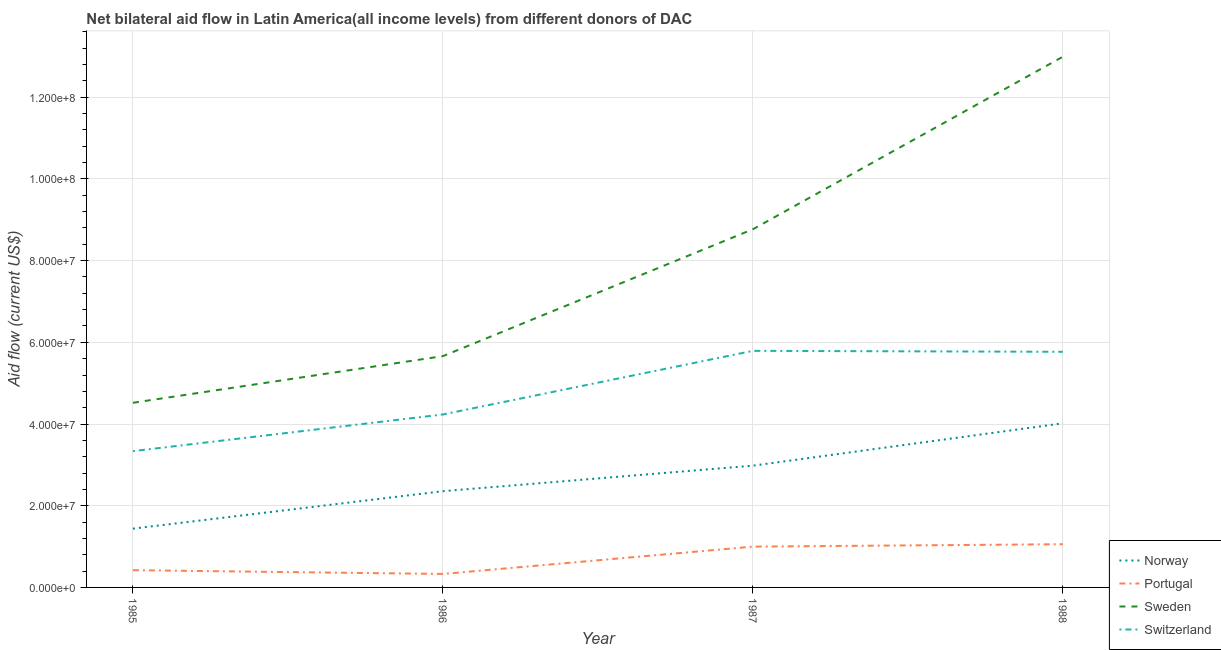How many different coloured lines are there?
Offer a terse response. 4. What is the amount of aid given by norway in 1988?
Your answer should be compact. 4.02e+07. Across all years, what is the maximum amount of aid given by sweden?
Your answer should be very brief. 1.30e+08. Across all years, what is the minimum amount of aid given by sweden?
Offer a terse response. 4.52e+07. What is the total amount of aid given by portugal in the graph?
Make the answer very short. 2.81e+07. What is the difference between the amount of aid given by portugal in 1985 and that in 1988?
Ensure brevity in your answer.  -6.36e+06. What is the difference between the amount of aid given by switzerland in 1988 and the amount of aid given by norway in 1986?
Your answer should be very brief. 3.41e+07. What is the average amount of aid given by switzerland per year?
Your answer should be very brief. 4.78e+07. In the year 1986, what is the difference between the amount of aid given by sweden and amount of aid given by portugal?
Give a very brief answer. 5.33e+07. In how many years, is the amount of aid given by sweden greater than 40000000 US$?
Ensure brevity in your answer.  4. What is the ratio of the amount of aid given by norway in 1985 to that in 1988?
Keep it short and to the point. 0.36. What is the difference between the highest and the second highest amount of aid given by sweden?
Make the answer very short. 4.22e+07. What is the difference between the highest and the lowest amount of aid given by portugal?
Give a very brief answer. 7.28e+06. In how many years, is the amount of aid given by switzerland greater than the average amount of aid given by switzerland taken over all years?
Make the answer very short. 2. Is the sum of the amount of aid given by norway in 1985 and 1986 greater than the maximum amount of aid given by sweden across all years?
Make the answer very short. No. Is it the case that in every year, the sum of the amount of aid given by norway and amount of aid given by sweden is greater than the sum of amount of aid given by switzerland and amount of aid given by portugal?
Your answer should be very brief. Yes. Does the amount of aid given by portugal monotonically increase over the years?
Offer a very short reply. No. Is the amount of aid given by switzerland strictly greater than the amount of aid given by portugal over the years?
Your response must be concise. Yes. How many years are there in the graph?
Your response must be concise. 4. What is the difference between two consecutive major ticks on the Y-axis?
Give a very brief answer. 2.00e+07. Are the values on the major ticks of Y-axis written in scientific E-notation?
Give a very brief answer. Yes. Does the graph contain grids?
Your answer should be compact. Yes. How many legend labels are there?
Offer a very short reply. 4. How are the legend labels stacked?
Offer a very short reply. Vertical. What is the title of the graph?
Offer a very short reply. Net bilateral aid flow in Latin America(all income levels) from different donors of DAC. Does "Secondary vocational" appear as one of the legend labels in the graph?
Give a very brief answer. No. What is the label or title of the X-axis?
Your answer should be compact. Year. What is the Aid flow (current US$) of Norway in 1985?
Ensure brevity in your answer.  1.44e+07. What is the Aid flow (current US$) in Portugal in 1985?
Your answer should be compact. 4.22e+06. What is the Aid flow (current US$) of Sweden in 1985?
Give a very brief answer. 4.52e+07. What is the Aid flow (current US$) of Switzerland in 1985?
Provide a succinct answer. 3.34e+07. What is the Aid flow (current US$) of Norway in 1986?
Keep it short and to the point. 2.36e+07. What is the Aid flow (current US$) in Portugal in 1986?
Make the answer very short. 3.30e+06. What is the Aid flow (current US$) of Sweden in 1986?
Keep it short and to the point. 5.66e+07. What is the Aid flow (current US$) in Switzerland in 1986?
Offer a very short reply. 4.23e+07. What is the Aid flow (current US$) in Norway in 1987?
Give a very brief answer. 2.98e+07. What is the Aid flow (current US$) of Portugal in 1987?
Keep it short and to the point. 9.99e+06. What is the Aid flow (current US$) of Sweden in 1987?
Offer a very short reply. 8.77e+07. What is the Aid flow (current US$) of Switzerland in 1987?
Offer a terse response. 5.79e+07. What is the Aid flow (current US$) of Norway in 1988?
Offer a terse response. 4.02e+07. What is the Aid flow (current US$) in Portugal in 1988?
Ensure brevity in your answer.  1.06e+07. What is the Aid flow (current US$) in Sweden in 1988?
Provide a short and direct response. 1.30e+08. What is the Aid flow (current US$) of Switzerland in 1988?
Ensure brevity in your answer.  5.77e+07. Across all years, what is the maximum Aid flow (current US$) in Norway?
Ensure brevity in your answer.  4.02e+07. Across all years, what is the maximum Aid flow (current US$) in Portugal?
Offer a terse response. 1.06e+07. Across all years, what is the maximum Aid flow (current US$) of Sweden?
Your answer should be compact. 1.30e+08. Across all years, what is the maximum Aid flow (current US$) in Switzerland?
Provide a succinct answer. 5.79e+07. Across all years, what is the minimum Aid flow (current US$) in Norway?
Your answer should be very brief. 1.44e+07. Across all years, what is the minimum Aid flow (current US$) of Portugal?
Offer a terse response. 3.30e+06. Across all years, what is the minimum Aid flow (current US$) of Sweden?
Keep it short and to the point. 4.52e+07. Across all years, what is the minimum Aid flow (current US$) in Switzerland?
Your response must be concise. 3.34e+07. What is the total Aid flow (current US$) in Norway in the graph?
Make the answer very short. 1.08e+08. What is the total Aid flow (current US$) in Portugal in the graph?
Provide a short and direct response. 2.81e+07. What is the total Aid flow (current US$) in Sweden in the graph?
Provide a succinct answer. 3.19e+08. What is the total Aid flow (current US$) in Switzerland in the graph?
Provide a succinct answer. 1.91e+08. What is the difference between the Aid flow (current US$) in Norway in 1985 and that in 1986?
Provide a short and direct response. -9.17e+06. What is the difference between the Aid flow (current US$) of Portugal in 1985 and that in 1986?
Your response must be concise. 9.20e+05. What is the difference between the Aid flow (current US$) in Sweden in 1985 and that in 1986?
Provide a short and direct response. -1.14e+07. What is the difference between the Aid flow (current US$) in Switzerland in 1985 and that in 1986?
Ensure brevity in your answer.  -8.98e+06. What is the difference between the Aid flow (current US$) in Norway in 1985 and that in 1987?
Provide a short and direct response. -1.54e+07. What is the difference between the Aid flow (current US$) in Portugal in 1985 and that in 1987?
Your answer should be compact. -5.77e+06. What is the difference between the Aid flow (current US$) in Sweden in 1985 and that in 1987?
Offer a terse response. -4.25e+07. What is the difference between the Aid flow (current US$) of Switzerland in 1985 and that in 1987?
Provide a succinct answer. -2.46e+07. What is the difference between the Aid flow (current US$) in Norway in 1985 and that in 1988?
Give a very brief answer. -2.58e+07. What is the difference between the Aid flow (current US$) in Portugal in 1985 and that in 1988?
Make the answer very short. -6.36e+06. What is the difference between the Aid flow (current US$) of Sweden in 1985 and that in 1988?
Your answer should be very brief. -8.47e+07. What is the difference between the Aid flow (current US$) of Switzerland in 1985 and that in 1988?
Give a very brief answer. -2.43e+07. What is the difference between the Aid flow (current US$) of Norway in 1986 and that in 1987?
Keep it short and to the point. -6.25e+06. What is the difference between the Aid flow (current US$) of Portugal in 1986 and that in 1987?
Make the answer very short. -6.69e+06. What is the difference between the Aid flow (current US$) of Sweden in 1986 and that in 1987?
Your answer should be compact. -3.11e+07. What is the difference between the Aid flow (current US$) in Switzerland in 1986 and that in 1987?
Provide a short and direct response. -1.56e+07. What is the difference between the Aid flow (current US$) of Norway in 1986 and that in 1988?
Your response must be concise. -1.66e+07. What is the difference between the Aid flow (current US$) of Portugal in 1986 and that in 1988?
Offer a terse response. -7.28e+06. What is the difference between the Aid flow (current US$) in Sweden in 1986 and that in 1988?
Give a very brief answer. -7.33e+07. What is the difference between the Aid flow (current US$) of Switzerland in 1986 and that in 1988?
Offer a very short reply. -1.53e+07. What is the difference between the Aid flow (current US$) of Norway in 1987 and that in 1988?
Provide a succinct answer. -1.04e+07. What is the difference between the Aid flow (current US$) in Portugal in 1987 and that in 1988?
Make the answer very short. -5.90e+05. What is the difference between the Aid flow (current US$) of Sweden in 1987 and that in 1988?
Offer a very short reply. -4.22e+07. What is the difference between the Aid flow (current US$) in Norway in 1985 and the Aid flow (current US$) in Portugal in 1986?
Provide a succinct answer. 1.11e+07. What is the difference between the Aid flow (current US$) of Norway in 1985 and the Aid flow (current US$) of Sweden in 1986?
Your answer should be compact. -4.22e+07. What is the difference between the Aid flow (current US$) of Norway in 1985 and the Aid flow (current US$) of Switzerland in 1986?
Offer a very short reply. -2.80e+07. What is the difference between the Aid flow (current US$) of Portugal in 1985 and the Aid flow (current US$) of Sweden in 1986?
Your answer should be very brief. -5.24e+07. What is the difference between the Aid flow (current US$) of Portugal in 1985 and the Aid flow (current US$) of Switzerland in 1986?
Keep it short and to the point. -3.81e+07. What is the difference between the Aid flow (current US$) in Sweden in 1985 and the Aid flow (current US$) in Switzerland in 1986?
Keep it short and to the point. 2.86e+06. What is the difference between the Aid flow (current US$) in Norway in 1985 and the Aid flow (current US$) in Portugal in 1987?
Offer a terse response. 4.40e+06. What is the difference between the Aid flow (current US$) in Norway in 1985 and the Aid flow (current US$) in Sweden in 1987?
Provide a succinct answer. -7.33e+07. What is the difference between the Aid flow (current US$) in Norway in 1985 and the Aid flow (current US$) in Switzerland in 1987?
Keep it short and to the point. -4.35e+07. What is the difference between the Aid flow (current US$) of Portugal in 1985 and the Aid flow (current US$) of Sweden in 1987?
Provide a succinct answer. -8.35e+07. What is the difference between the Aid flow (current US$) in Portugal in 1985 and the Aid flow (current US$) in Switzerland in 1987?
Provide a short and direct response. -5.37e+07. What is the difference between the Aid flow (current US$) of Sweden in 1985 and the Aid flow (current US$) of Switzerland in 1987?
Make the answer very short. -1.27e+07. What is the difference between the Aid flow (current US$) in Norway in 1985 and the Aid flow (current US$) in Portugal in 1988?
Ensure brevity in your answer.  3.81e+06. What is the difference between the Aid flow (current US$) of Norway in 1985 and the Aid flow (current US$) of Sweden in 1988?
Your answer should be compact. -1.16e+08. What is the difference between the Aid flow (current US$) in Norway in 1985 and the Aid flow (current US$) in Switzerland in 1988?
Offer a terse response. -4.33e+07. What is the difference between the Aid flow (current US$) of Portugal in 1985 and the Aid flow (current US$) of Sweden in 1988?
Your answer should be compact. -1.26e+08. What is the difference between the Aid flow (current US$) of Portugal in 1985 and the Aid flow (current US$) of Switzerland in 1988?
Keep it short and to the point. -5.35e+07. What is the difference between the Aid flow (current US$) in Sweden in 1985 and the Aid flow (current US$) in Switzerland in 1988?
Provide a short and direct response. -1.25e+07. What is the difference between the Aid flow (current US$) in Norway in 1986 and the Aid flow (current US$) in Portugal in 1987?
Ensure brevity in your answer.  1.36e+07. What is the difference between the Aid flow (current US$) of Norway in 1986 and the Aid flow (current US$) of Sweden in 1987?
Give a very brief answer. -6.41e+07. What is the difference between the Aid flow (current US$) in Norway in 1986 and the Aid flow (current US$) in Switzerland in 1987?
Give a very brief answer. -3.44e+07. What is the difference between the Aid flow (current US$) of Portugal in 1986 and the Aid flow (current US$) of Sweden in 1987?
Keep it short and to the point. -8.44e+07. What is the difference between the Aid flow (current US$) in Portugal in 1986 and the Aid flow (current US$) in Switzerland in 1987?
Offer a terse response. -5.46e+07. What is the difference between the Aid flow (current US$) in Sweden in 1986 and the Aid flow (current US$) in Switzerland in 1987?
Your answer should be compact. -1.29e+06. What is the difference between the Aid flow (current US$) of Norway in 1986 and the Aid flow (current US$) of Portugal in 1988?
Give a very brief answer. 1.30e+07. What is the difference between the Aid flow (current US$) in Norway in 1986 and the Aid flow (current US$) in Sweden in 1988?
Offer a very short reply. -1.06e+08. What is the difference between the Aid flow (current US$) of Norway in 1986 and the Aid flow (current US$) of Switzerland in 1988?
Make the answer very short. -3.41e+07. What is the difference between the Aid flow (current US$) of Portugal in 1986 and the Aid flow (current US$) of Sweden in 1988?
Keep it short and to the point. -1.27e+08. What is the difference between the Aid flow (current US$) in Portugal in 1986 and the Aid flow (current US$) in Switzerland in 1988?
Your response must be concise. -5.44e+07. What is the difference between the Aid flow (current US$) in Sweden in 1986 and the Aid flow (current US$) in Switzerland in 1988?
Provide a succinct answer. -1.06e+06. What is the difference between the Aid flow (current US$) of Norway in 1987 and the Aid flow (current US$) of Portugal in 1988?
Provide a short and direct response. 1.92e+07. What is the difference between the Aid flow (current US$) of Norway in 1987 and the Aid flow (current US$) of Sweden in 1988?
Your answer should be compact. -1.00e+08. What is the difference between the Aid flow (current US$) in Norway in 1987 and the Aid flow (current US$) in Switzerland in 1988?
Ensure brevity in your answer.  -2.79e+07. What is the difference between the Aid flow (current US$) of Portugal in 1987 and the Aid flow (current US$) of Sweden in 1988?
Provide a short and direct response. -1.20e+08. What is the difference between the Aid flow (current US$) in Portugal in 1987 and the Aid flow (current US$) in Switzerland in 1988?
Your answer should be very brief. -4.77e+07. What is the difference between the Aid flow (current US$) of Sweden in 1987 and the Aid flow (current US$) of Switzerland in 1988?
Your response must be concise. 3.00e+07. What is the average Aid flow (current US$) in Norway per year?
Ensure brevity in your answer.  2.70e+07. What is the average Aid flow (current US$) in Portugal per year?
Your answer should be compact. 7.02e+06. What is the average Aid flow (current US$) of Sweden per year?
Your answer should be very brief. 7.99e+07. What is the average Aid flow (current US$) in Switzerland per year?
Ensure brevity in your answer.  4.78e+07. In the year 1985, what is the difference between the Aid flow (current US$) of Norway and Aid flow (current US$) of Portugal?
Make the answer very short. 1.02e+07. In the year 1985, what is the difference between the Aid flow (current US$) in Norway and Aid flow (current US$) in Sweden?
Provide a short and direct response. -3.08e+07. In the year 1985, what is the difference between the Aid flow (current US$) of Norway and Aid flow (current US$) of Switzerland?
Ensure brevity in your answer.  -1.90e+07. In the year 1985, what is the difference between the Aid flow (current US$) of Portugal and Aid flow (current US$) of Sweden?
Your answer should be compact. -4.10e+07. In the year 1985, what is the difference between the Aid flow (current US$) of Portugal and Aid flow (current US$) of Switzerland?
Provide a short and direct response. -2.91e+07. In the year 1985, what is the difference between the Aid flow (current US$) of Sweden and Aid flow (current US$) of Switzerland?
Provide a short and direct response. 1.18e+07. In the year 1986, what is the difference between the Aid flow (current US$) of Norway and Aid flow (current US$) of Portugal?
Make the answer very short. 2.03e+07. In the year 1986, what is the difference between the Aid flow (current US$) in Norway and Aid flow (current US$) in Sweden?
Offer a very short reply. -3.31e+07. In the year 1986, what is the difference between the Aid flow (current US$) of Norway and Aid flow (current US$) of Switzerland?
Your answer should be compact. -1.88e+07. In the year 1986, what is the difference between the Aid flow (current US$) of Portugal and Aid flow (current US$) of Sweden?
Ensure brevity in your answer.  -5.33e+07. In the year 1986, what is the difference between the Aid flow (current US$) of Portugal and Aid flow (current US$) of Switzerland?
Keep it short and to the point. -3.90e+07. In the year 1986, what is the difference between the Aid flow (current US$) in Sweden and Aid flow (current US$) in Switzerland?
Your answer should be very brief. 1.43e+07. In the year 1987, what is the difference between the Aid flow (current US$) in Norway and Aid flow (current US$) in Portugal?
Your answer should be compact. 1.98e+07. In the year 1987, what is the difference between the Aid flow (current US$) in Norway and Aid flow (current US$) in Sweden?
Offer a terse response. -5.79e+07. In the year 1987, what is the difference between the Aid flow (current US$) in Norway and Aid flow (current US$) in Switzerland?
Keep it short and to the point. -2.81e+07. In the year 1987, what is the difference between the Aid flow (current US$) of Portugal and Aid flow (current US$) of Sweden?
Keep it short and to the point. -7.77e+07. In the year 1987, what is the difference between the Aid flow (current US$) in Portugal and Aid flow (current US$) in Switzerland?
Provide a short and direct response. -4.79e+07. In the year 1987, what is the difference between the Aid flow (current US$) of Sweden and Aid flow (current US$) of Switzerland?
Your response must be concise. 2.98e+07. In the year 1988, what is the difference between the Aid flow (current US$) of Norway and Aid flow (current US$) of Portugal?
Make the answer very short. 2.96e+07. In the year 1988, what is the difference between the Aid flow (current US$) of Norway and Aid flow (current US$) of Sweden?
Your answer should be very brief. -8.97e+07. In the year 1988, what is the difference between the Aid flow (current US$) of Norway and Aid flow (current US$) of Switzerland?
Make the answer very short. -1.75e+07. In the year 1988, what is the difference between the Aid flow (current US$) of Portugal and Aid flow (current US$) of Sweden?
Provide a short and direct response. -1.19e+08. In the year 1988, what is the difference between the Aid flow (current US$) of Portugal and Aid flow (current US$) of Switzerland?
Offer a terse response. -4.71e+07. In the year 1988, what is the difference between the Aid flow (current US$) of Sweden and Aid flow (current US$) of Switzerland?
Your answer should be very brief. 7.22e+07. What is the ratio of the Aid flow (current US$) of Norway in 1985 to that in 1986?
Your response must be concise. 0.61. What is the ratio of the Aid flow (current US$) in Portugal in 1985 to that in 1986?
Keep it short and to the point. 1.28. What is the ratio of the Aid flow (current US$) in Sweden in 1985 to that in 1986?
Ensure brevity in your answer.  0.8. What is the ratio of the Aid flow (current US$) of Switzerland in 1985 to that in 1986?
Provide a short and direct response. 0.79. What is the ratio of the Aid flow (current US$) of Norway in 1985 to that in 1987?
Offer a very short reply. 0.48. What is the ratio of the Aid flow (current US$) of Portugal in 1985 to that in 1987?
Offer a very short reply. 0.42. What is the ratio of the Aid flow (current US$) of Sweden in 1985 to that in 1987?
Give a very brief answer. 0.52. What is the ratio of the Aid flow (current US$) in Switzerland in 1985 to that in 1987?
Give a very brief answer. 0.58. What is the ratio of the Aid flow (current US$) in Norway in 1985 to that in 1988?
Offer a very short reply. 0.36. What is the ratio of the Aid flow (current US$) of Portugal in 1985 to that in 1988?
Make the answer very short. 0.4. What is the ratio of the Aid flow (current US$) of Sweden in 1985 to that in 1988?
Provide a short and direct response. 0.35. What is the ratio of the Aid flow (current US$) in Switzerland in 1985 to that in 1988?
Ensure brevity in your answer.  0.58. What is the ratio of the Aid flow (current US$) of Norway in 1986 to that in 1987?
Ensure brevity in your answer.  0.79. What is the ratio of the Aid flow (current US$) of Portugal in 1986 to that in 1987?
Provide a short and direct response. 0.33. What is the ratio of the Aid flow (current US$) of Sweden in 1986 to that in 1987?
Provide a short and direct response. 0.65. What is the ratio of the Aid flow (current US$) of Switzerland in 1986 to that in 1987?
Give a very brief answer. 0.73. What is the ratio of the Aid flow (current US$) in Norway in 1986 to that in 1988?
Give a very brief answer. 0.59. What is the ratio of the Aid flow (current US$) of Portugal in 1986 to that in 1988?
Offer a very short reply. 0.31. What is the ratio of the Aid flow (current US$) in Sweden in 1986 to that in 1988?
Offer a terse response. 0.44. What is the ratio of the Aid flow (current US$) of Switzerland in 1986 to that in 1988?
Make the answer very short. 0.73. What is the ratio of the Aid flow (current US$) in Norway in 1987 to that in 1988?
Offer a very short reply. 0.74. What is the ratio of the Aid flow (current US$) of Portugal in 1987 to that in 1988?
Make the answer very short. 0.94. What is the ratio of the Aid flow (current US$) in Sweden in 1987 to that in 1988?
Give a very brief answer. 0.67. What is the difference between the highest and the second highest Aid flow (current US$) in Norway?
Give a very brief answer. 1.04e+07. What is the difference between the highest and the second highest Aid flow (current US$) in Portugal?
Provide a short and direct response. 5.90e+05. What is the difference between the highest and the second highest Aid flow (current US$) of Sweden?
Provide a short and direct response. 4.22e+07. What is the difference between the highest and the second highest Aid flow (current US$) in Switzerland?
Give a very brief answer. 2.30e+05. What is the difference between the highest and the lowest Aid flow (current US$) in Norway?
Your response must be concise. 2.58e+07. What is the difference between the highest and the lowest Aid flow (current US$) in Portugal?
Offer a terse response. 7.28e+06. What is the difference between the highest and the lowest Aid flow (current US$) in Sweden?
Give a very brief answer. 8.47e+07. What is the difference between the highest and the lowest Aid flow (current US$) in Switzerland?
Offer a very short reply. 2.46e+07. 